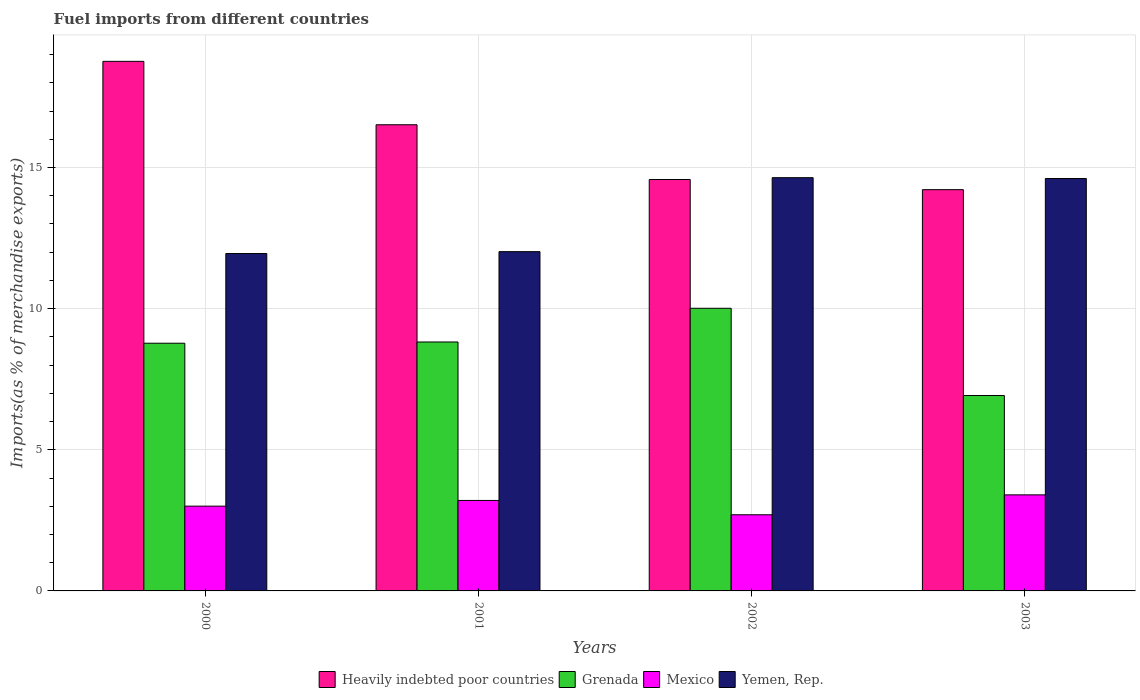How many groups of bars are there?
Provide a succinct answer. 4. Are the number of bars per tick equal to the number of legend labels?
Your answer should be compact. Yes. How many bars are there on the 3rd tick from the left?
Your response must be concise. 4. How many bars are there on the 4th tick from the right?
Your answer should be compact. 4. What is the label of the 1st group of bars from the left?
Your answer should be compact. 2000. In how many cases, is the number of bars for a given year not equal to the number of legend labels?
Provide a short and direct response. 0. What is the percentage of imports to different countries in Mexico in 2003?
Give a very brief answer. 3.4. Across all years, what is the maximum percentage of imports to different countries in Heavily indebted poor countries?
Keep it short and to the point. 18.76. Across all years, what is the minimum percentage of imports to different countries in Grenada?
Make the answer very short. 6.92. In which year was the percentage of imports to different countries in Heavily indebted poor countries minimum?
Give a very brief answer. 2003. What is the total percentage of imports to different countries in Heavily indebted poor countries in the graph?
Provide a succinct answer. 64.07. What is the difference between the percentage of imports to different countries in Mexico in 2000 and that in 2002?
Give a very brief answer. 0.31. What is the difference between the percentage of imports to different countries in Mexico in 2003 and the percentage of imports to different countries in Heavily indebted poor countries in 2002?
Your response must be concise. -11.17. What is the average percentage of imports to different countries in Mexico per year?
Ensure brevity in your answer.  3.08. In the year 2000, what is the difference between the percentage of imports to different countries in Grenada and percentage of imports to different countries in Mexico?
Make the answer very short. 5.77. What is the ratio of the percentage of imports to different countries in Grenada in 2002 to that in 2003?
Offer a terse response. 1.45. Is the difference between the percentage of imports to different countries in Grenada in 2000 and 2002 greater than the difference between the percentage of imports to different countries in Mexico in 2000 and 2002?
Offer a terse response. No. What is the difference between the highest and the second highest percentage of imports to different countries in Mexico?
Offer a very short reply. 0.2. What is the difference between the highest and the lowest percentage of imports to different countries in Mexico?
Your response must be concise. 0.71. Is it the case that in every year, the sum of the percentage of imports to different countries in Heavily indebted poor countries and percentage of imports to different countries in Grenada is greater than the sum of percentage of imports to different countries in Mexico and percentage of imports to different countries in Yemen, Rep.?
Provide a succinct answer. Yes. What does the 4th bar from the left in 2003 represents?
Your answer should be compact. Yemen, Rep. What does the 2nd bar from the right in 2002 represents?
Provide a succinct answer. Mexico. Are all the bars in the graph horizontal?
Ensure brevity in your answer.  No. Are the values on the major ticks of Y-axis written in scientific E-notation?
Your answer should be compact. No. Does the graph contain grids?
Provide a succinct answer. Yes. How many legend labels are there?
Your answer should be very brief. 4. What is the title of the graph?
Your answer should be compact. Fuel imports from different countries. What is the label or title of the Y-axis?
Keep it short and to the point. Imports(as % of merchandise exports). What is the Imports(as % of merchandise exports) in Heavily indebted poor countries in 2000?
Provide a succinct answer. 18.76. What is the Imports(as % of merchandise exports) in Grenada in 2000?
Your response must be concise. 8.78. What is the Imports(as % of merchandise exports) in Mexico in 2000?
Offer a very short reply. 3. What is the Imports(as % of merchandise exports) of Yemen, Rep. in 2000?
Provide a short and direct response. 11.95. What is the Imports(as % of merchandise exports) of Heavily indebted poor countries in 2001?
Offer a very short reply. 16.51. What is the Imports(as % of merchandise exports) in Grenada in 2001?
Provide a short and direct response. 8.82. What is the Imports(as % of merchandise exports) in Mexico in 2001?
Your answer should be very brief. 3.21. What is the Imports(as % of merchandise exports) of Yemen, Rep. in 2001?
Your answer should be compact. 12.02. What is the Imports(as % of merchandise exports) in Heavily indebted poor countries in 2002?
Keep it short and to the point. 14.58. What is the Imports(as % of merchandise exports) in Grenada in 2002?
Ensure brevity in your answer.  10.01. What is the Imports(as % of merchandise exports) in Mexico in 2002?
Offer a terse response. 2.7. What is the Imports(as % of merchandise exports) of Yemen, Rep. in 2002?
Offer a very short reply. 14.64. What is the Imports(as % of merchandise exports) of Heavily indebted poor countries in 2003?
Offer a terse response. 14.21. What is the Imports(as % of merchandise exports) of Grenada in 2003?
Offer a terse response. 6.92. What is the Imports(as % of merchandise exports) in Mexico in 2003?
Provide a short and direct response. 3.4. What is the Imports(as % of merchandise exports) in Yemen, Rep. in 2003?
Make the answer very short. 14.61. Across all years, what is the maximum Imports(as % of merchandise exports) in Heavily indebted poor countries?
Give a very brief answer. 18.76. Across all years, what is the maximum Imports(as % of merchandise exports) in Grenada?
Give a very brief answer. 10.01. Across all years, what is the maximum Imports(as % of merchandise exports) of Mexico?
Provide a succinct answer. 3.4. Across all years, what is the maximum Imports(as % of merchandise exports) of Yemen, Rep.?
Provide a succinct answer. 14.64. Across all years, what is the minimum Imports(as % of merchandise exports) of Heavily indebted poor countries?
Offer a very short reply. 14.21. Across all years, what is the minimum Imports(as % of merchandise exports) of Grenada?
Provide a succinct answer. 6.92. Across all years, what is the minimum Imports(as % of merchandise exports) in Mexico?
Your answer should be very brief. 2.7. Across all years, what is the minimum Imports(as % of merchandise exports) of Yemen, Rep.?
Offer a terse response. 11.95. What is the total Imports(as % of merchandise exports) of Heavily indebted poor countries in the graph?
Give a very brief answer. 64.07. What is the total Imports(as % of merchandise exports) in Grenada in the graph?
Keep it short and to the point. 34.53. What is the total Imports(as % of merchandise exports) in Mexico in the graph?
Provide a short and direct response. 12.31. What is the total Imports(as % of merchandise exports) in Yemen, Rep. in the graph?
Your response must be concise. 53.22. What is the difference between the Imports(as % of merchandise exports) of Heavily indebted poor countries in 2000 and that in 2001?
Offer a terse response. 2.25. What is the difference between the Imports(as % of merchandise exports) in Grenada in 2000 and that in 2001?
Your answer should be very brief. -0.04. What is the difference between the Imports(as % of merchandise exports) in Mexico in 2000 and that in 2001?
Keep it short and to the point. -0.2. What is the difference between the Imports(as % of merchandise exports) of Yemen, Rep. in 2000 and that in 2001?
Provide a succinct answer. -0.07. What is the difference between the Imports(as % of merchandise exports) of Heavily indebted poor countries in 2000 and that in 2002?
Provide a succinct answer. 4.19. What is the difference between the Imports(as % of merchandise exports) of Grenada in 2000 and that in 2002?
Offer a very short reply. -1.24. What is the difference between the Imports(as % of merchandise exports) of Mexico in 2000 and that in 2002?
Offer a terse response. 0.31. What is the difference between the Imports(as % of merchandise exports) of Yemen, Rep. in 2000 and that in 2002?
Provide a succinct answer. -2.69. What is the difference between the Imports(as % of merchandise exports) in Heavily indebted poor countries in 2000 and that in 2003?
Give a very brief answer. 4.55. What is the difference between the Imports(as % of merchandise exports) of Grenada in 2000 and that in 2003?
Make the answer very short. 1.85. What is the difference between the Imports(as % of merchandise exports) of Mexico in 2000 and that in 2003?
Provide a succinct answer. -0.4. What is the difference between the Imports(as % of merchandise exports) of Yemen, Rep. in 2000 and that in 2003?
Your answer should be very brief. -2.66. What is the difference between the Imports(as % of merchandise exports) in Heavily indebted poor countries in 2001 and that in 2002?
Provide a succinct answer. 1.94. What is the difference between the Imports(as % of merchandise exports) of Grenada in 2001 and that in 2002?
Your answer should be compact. -1.19. What is the difference between the Imports(as % of merchandise exports) in Mexico in 2001 and that in 2002?
Ensure brevity in your answer.  0.51. What is the difference between the Imports(as % of merchandise exports) of Yemen, Rep. in 2001 and that in 2002?
Provide a short and direct response. -2.62. What is the difference between the Imports(as % of merchandise exports) in Heavily indebted poor countries in 2001 and that in 2003?
Offer a terse response. 2.3. What is the difference between the Imports(as % of merchandise exports) of Grenada in 2001 and that in 2003?
Your answer should be compact. 1.9. What is the difference between the Imports(as % of merchandise exports) in Mexico in 2001 and that in 2003?
Make the answer very short. -0.2. What is the difference between the Imports(as % of merchandise exports) in Yemen, Rep. in 2001 and that in 2003?
Your answer should be compact. -2.59. What is the difference between the Imports(as % of merchandise exports) in Heavily indebted poor countries in 2002 and that in 2003?
Make the answer very short. 0.36. What is the difference between the Imports(as % of merchandise exports) of Grenada in 2002 and that in 2003?
Offer a terse response. 3.09. What is the difference between the Imports(as % of merchandise exports) of Mexico in 2002 and that in 2003?
Your response must be concise. -0.71. What is the difference between the Imports(as % of merchandise exports) in Yemen, Rep. in 2002 and that in 2003?
Provide a short and direct response. 0.03. What is the difference between the Imports(as % of merchandise exports) of Heavily indebted poor countries in 2000 and the Imports(as % of merchandise exports) of Grenada in 2001?
Provide a short and direct response. 9.94. What is the difference between the Imports(as % of merchandise exports) of Heavily indebted poor countries in 2000 and the Imports(as % of merchandise exports) of Mexico in 2001?
Your answer should be very brief. 15.56. What is the difference between the Imports(as % of merchandise exports) of Heavily indebted poor countries in 2000 and the Imports(as % of merchandise exports) of Yemen, Rep. in 2001?
Your answer should be very brief. 6.74. What is the difference between the Imports(as % of merchandise exports) of Grenada in 2000 and the Imports(as % of merchandise exports) of Mexico in 2001?
Offer a very short reply. 5.57. What is the difference between the Imports(as % of merchandise exports) in Grenada in 2000 and the Imports(as % of merchandise exports) in Yemen, Rep. in 2001?
Offer a terse response. -3.24. What is the difference between the Imports(as % of merchandise exports) of Mexico in 2000 and the Imports(as % of merchandise exports) of Yemen, Rep. in 2001?
Keep it short and to the point. -9.02. What is the difference between the Imports(as % of merchandise exports) of Heavily indebted poor countries in 2000 and the Imports(as % of merchandise exports) of Grenada in 2002?
Your answer should be compact. 8.75. What is the difference between the Imports(as % of merchandise exports) of Heavily indebted poor countries in 2000 and the Imports(as % of merchandise exports) of Mexico in 2002?
Your response must be concise. 16.06. What is the difference between the Imports(as % of merchandise exports) of Heavily indebted poor countries in 2000 and the Imports(as % of merchandise exports) of Yemen, Rep. in 2002?
Your answer should be compact. 4.12. What is the difference between the Imports(as % of merchandise exports) of Grenada in 2000 and the Imports(as % of merchandise exports) of Mexico in 2002?
Make the answer very short. 6.08. What is the difference between the Imports(as % of merchandise exports) of Grenada in 2000 and the Imports(as % of merchandise exports) of Yemen, Rep. in 2002?
Ensure brevity in your answer.  -5.86. What is the difference between the Imports(as % of merchandise exports) in Mexico in 2000 and the Imports(as % of merchandise exports) in Yemen, Rep. in 2002?
Provide a short and direct response. -11.64. What is the difference between the Imports(as % of merchandise exports) of Heavily indebted poor countries in 2000 and the Imports(as % of merchandise exports) of Grenada in 2003?
Your answer should be very brief. 11.84. What is the difference between the Imports(as % of merchandise exports) in Heavily indebted poor countries in 2000 and the Imports(as % of merchandise exports) in Mexico in 2003?
Make the answer very short. 15.36. What is the difference between the Imports(as % of merchandise exports) in Heavily indebted poor countries in 2000 and the Imports(as % of merchandise exports) in Yemen, Rep. in 2003?
Ensure brevity in your answer.  4.15. What is the difference between the Imports(as % of merchandise exports) in Grenada in 2000 and the Imports(as % of merchandise exports) in Mexico in 2003?
Give a very brief answer. 5.37. What is the difference between the Imports(as % of merchandise exports) of Grenada in 2000 and the Imports(as % of merchandise exports) of Yemen, Rep. in 2003?
Make the answer very short. -5.84. What is the difference between the Imports(as % of merchandise exports) of Mexico in 2000 and the Imports(as % of merchandise exports) of Yemen, Rep. in 2003?
Your response must be concise. -11.61. What is the difference between the Imports(as % of merchandise exports) of Heavily indebted poor countries in 2001 and the Imports(as % of merchandise exports) of Grenada in 2002?
Offer a very short reply. 6.5. What is the difference between the Imports(as % of merchandise exports) in Heavily indebted poor countries in 2001 and the Imports(as % of merchandise exports) in Mexico in 2002?
Offer a terse response. 13.82. What is the difference between the Imports(as % of merchandise exports) of Heavily indebted poor countries in 2001 and the Imports(as % of merchandise exports) of Yemen, Rep. in 2002?
Offer a very short reply. 1.87. What is the difference between the Imports(as % of merchandise exports) of Grenada in 2001 and the Imports(as % of merchandise exports) of Mexico in 2002?
Make the answer very short. 6.12. What is the difference between the Imports(as % of merchandise exports) in Grenada in 2001 and the Imports(as % of merchandise exports) in Yemen, Rep. in 2002?
Keep it short and to the point. -5.82. What is the difference between the Imports(as % of merchandise exports) in Mexico in 2001 and the Imports(as % of merchandise exports) in Yemen, Rep. in 2002?
Provide a succinct answer. -11.43. What is the difference between the Imports(as % of merchandise exports) in Heavily indebted poor countries in 2001 and the Imports(as % of merchandise exports) in Grenada in 2003?
Keep it short and to the point. 9.59. What is the difference between the Imports(as % of merchandise exports) of Heavily indebted poor countries in 2001 and the Imports(as % of merchandise exports) of Mexico in 2003?
Ensure brevity in your answer.  13.11. What is the difference between the Imports(as % of merchandise exports) in Heavily indebted poor countries in 2001 and the Imports(as % of merchandise exports) in Yemen, Rep. in 2003?
Offer a terse response. 1.9. What is the difference between the Imports(as % of merchandise exports) of Grenada in 2001 and the Imports(as % of merchandise exports) of Mexico in 2003?
Offer a terse response. 5.42. What is the difference between the Imports(as % of merchandise exports) of Grenada in 2001 and the Imports(as % of merchandise exports) of Yemen, Rep. in 2003?
Ensure brevity in your answer.  -5.79. What is the difference between the Imports(as % of merchandise exports) of Mexico in 2001 and the Imports(as % of merchandise exports) of Yemen, Rep. in 2003?
Make the answer very short. -11.41. What is the difference between the Imports(as % of merchandise exports) of Heavily indebted poor countries in 2002 and the Imports(as % of merchandise exports) of Grenada in 2003?
Give a very brief answer. 7.65. What is the difference between the Imports(as % of merchandise exports) of Heavily indebted poor countries in 2002 and the Imports(as % of merchandise exports) of Mexico in 2003?
Make the answer very short. 11.17. What is the difference between the Imports(as % of merchandise exports) of Heavily indebted poor countries in 2002 and the Imports(as % of merchandise exports) of Yemen, Rep. in 2003?
Give a very brief answer. -0.03. What is the difference between the Imports(as % of merchandise exports) in Grenada in 2002 and the Imports(as % of merchandise exports) in Mexico in 2003?
Keep it short and to the point. 6.61. What is the difference between the Imports(as % of merchandise exports) in Grenada in 2002 and the Imports(as % of merchandise exports) in Yemen, Rep. in 2003?
Keep it short and to the point. -4.6. What is the difference between the Imports(as % of merchandise exports) of Mexico in 2002 and the Imports(as % of merchandise exports) of Yemen, Rep. in 2003?
Your response must be concise. -11.91. What is the average Imports(as % of merchandise exports) in Heavily indebted poor countries per year?
Ensure brevity in your answer.  16.02. What is the average Imports(as % of merchandise exports) in Grenada per year?
Provide a short and direct response. 8.63. What is the average Imports(as % of merchandise exports) of Mexico per year?
Your answer should be compact. 3.08. What is the average Imports(as % of merchandise exports) in Yemen, Rep. per year?
Your response must be concise. 13.31. In the year 2000, what is the difference between the Imports(as % of merchandise exports) in Heavily indebted poor countries and Imports(as % of merchandise exports) in Grenada?
Keep it short and to the point. 9.99. In the year 2000, what is the difference between the Imports(as % of merchandise exports) in Heavily indebted poor countries and Imports(as % of merchandise exports) in Mexico?
Your answer should be very brief. 15.76. In the year 2000, what is the difference between the Imports(as % of merchandise exports) in Heavily indebted poor countries and Imports(as % of merchandise exports) in Yemen, Rep.?
Provide a succinct answer. 6.81. In the year 2000, what is the difference between the Imports(as % of merchandise exports) in Grenada and Imports(as % of merchandise exports) in Mexico?
Provide a succinct answer. 5.77. In the year 2000, what is the difference between the Imports(as % of merchandise exports) of Grenada and Imports(as % of merchandise exports) of Yemen, Rep.?
Ensure brevity in your answer.  -3.18. In the year 2000, what is the difference between the Imports(as % of merchandise exports) of Mexico and Imports(as % of merchandise exports) of Yemen, Rep.?
Make the answer very short. -8.95. In the year 2001, what is the difference between the Imports(as % of merchandise exports) of Heavily indebted poor countries and Imports(as % of merchandise exports) of Grenada?
Give a very brief answer. 7.7. In the year 2001, what is the difference between the Imports(as % of merchandise exports) in Heavily indebted poor countries and Imports(as % of merchandise exports) in Mexico?
Provide a succinct answer. 13.31. In the year 2001, what is the difference between the Imports(as % of merchandise exports) in Heavily indebted poor countries and Imports(as % of merchandise exports) in Yemen, Rep.?
Make the answer very short. 4.49. In the year 2001, what is the difference between the Imports(as % of merchandise exports) of Grenada and Imports(as % of merchandise exports) of Mexico?
Offer a very short reply. 5.61. In the year 2001, what is the difference between the Imports(as % of merchandise exports) of Grenada and Imports(as % of merchandise exports) of Yemen, Rep.?
Offer a very short reply. -3.2. In the year 2001, what is the difference between the Imports(as % of merchandise exports) in Mexico and Imports(as % of merchandise exports) in Yemen, Rep.?
Offer a terse response. -8.81. In the year 2002, what is the difference between the Imports(as % of merchandise exports) of Heavily indebted poor countries and Imports(as % of merchandise exports) of Grenada?
Give a very brief answer. 4.56. In the year 2002, what is the difference between the Imports(as % of merchandise exports) in Heavily indebted poor countries and Imports(as % of merchandise exports) in Mexico?
Make the answer very short. 11.88. In the year 2002, what is the difference between the Imports(as % of merchandise exports) in Heavily indebted poor countries and Imports(as % of merchandise exports) in Yemen, Rep.?
Provide a short and direct response. -0.06. In the year 2002, what is the difference between the Imports(as % of merchandise exports) in Grenada and Imports(as % of merchandise exports) in Mexico?
Provide a short and direct response. 7.32. In the year 2002, what is the difference between the Imports(as % of merchandise exports) of Grenada and Imports(as % of merchandise exports) of Yemen, Rep.?
Your response must be concise. -4.63. In the year 2002, what is the difference between the Imports(as % of merchandise exports) in Mexico and Imports(as % of merchandise exports) in Yemen, Rep.?
Your answer should be compact. -11.94. In the year 2003, what is the difference between the Imports(as % of merchandise exports) in Heavily indebted poor countries and Imports(as % of merchandise exports) in Grenada?
Provide a succinct answer. 7.29. In the year 2003, what is the difference between the Imports(as % of merchandise exports) of Heavily indebted poor countries and Imports(as % of merchandise exports) of Mexico?
Make the answer very short. 10.81. In the year 2003, what is the difference between the Imports(as % of merchandise exports) of Heavily indebted poor countries and Imports(as % of merchandise exports) of Yemen, Rep.?
Offer a terse response. -0.4. In the year 2003, what is the difference between the Imports(as % of merchandise exports) in Grenada and Imports(as % of merchandise exports) in Mexico?
Offer a very short reply. 3.52. In the year 2003, what is the difference between the Imports(as % of merchandise exports) of Grenada and Imports(as % of merchandise exports) of Yemen, Rep.?
Your answer should be very brief. -7.69. In the year 2003, what is the difference between the Imports(as % of merchandise exports) of Mexico and Imports(as % of merchandise exports) of Yemen, Rep.?
Your answer should be very brief. -11.21. What is the ratio of the Imports(as % of merchandise exports) of Heavily indebted poor countries in 2000 to that in 2001?
Provide a succinct answer. 1.14. What is the ratio of the Imports(as % of merchandise exports) of Grenada in 2000 to that in 2001?
Provide a short and direct response. 1. What is the ratio of the Imports(as % of merchandise exports) in Mexico in 2000 to that in 2001?
Provide a succinct answer. 0.94. What is the ratio of the Imports(as % of merchandise exports) of Yemen, Rep. in 2000 to that in 2001?
Provide a short and direct response. 0.99. What is the ratio of the Imports(as % of merchandise exports) of Heavily indebted poor countries in 2000 to that in 2002?
Ensure brevity in your answer.  1.29. What is the ratio of the Imports(as % of merchandise exports) in Grenada in 2000 to that in 2002?
Provide a succinct answer. 0.88. What is the ratio of the Imports(as % of merchandise exports) of Mexico in 2000 to that in 2002?
Give a very brief answer. 1.11. What is the ratio of the Imports(as % of merchandise exports) of Yemen, Rep. in 2000 to that in 2002?
Provide a short and direct response. 0.82. What is the ratio of the Imports(as % of merchandise exports) of Heavily indebted poor countries in 2000 to that in 2003?
Offer a terse response. 1.32. What is the ratio of the Imports(as % of merchandise exports) in Grenada in 2000 to that in 2003?
Keep it short and to the point. 1.27. What is the ratio of the Imports(as % of merchandise exports) in Mexico in 2000 to that in 2003?
Give a very brief answer. 0.88. What is the ratio of the Imports(as % of merchandise exports) in Yemen, Rep. in 2000 to that in 2003?
Offer a very short reply. 0.82. What is the ratio of the Imports(as % of merchandise exports) in Heavily indebted poor countries in 2001 to that in 2002?
Your answer should be compact. 1.13. What is the ratio of the Imports(as % of merchandise exports) in Grenada in 2001 to that in 2002?
Make the answer very short. 0.88. What is the ratio of the Imports(as % of merchandise exports) in Mexico in 2001 to that in 2002?
Your response must be concise. 1.19. What is the ratio of the Imports(as % of merchandise exports) in Yemen, Rep. in 2001 to that in 2002?
Your response must be concise. 0.82. What is the ratio of the Imports(as % of merchandise exports) in Heavily indebted poor countries in 2001 to that in 2003?
Your answer should be compact. 1.16. What is the ratio of the Imports(as % of merchandise exports) of Grenada in 2001 to that in 2003?
Your answer should be compact. 1.27. What is the ratio of the Imports(as % of merchandise exports) in Mexico in 2001 to that in 2003?
Your answer should be very brief. 0.94. What is the ratio of the Imports(as % of merchandise exports) in Yemen, Rep. in 2001 to that in 2003?
Your response must be concise. 0.82. What is the ratio of the Imports(as % of merchandise exports) in Heavily indebted poor countries in 2002 to that in 2003?
Ensure brevity in your answer.  1.03. What is the ratio of the Imports(as % of merchandise exports) of Grenada in 2002 to that in 2003?
Your answer should be compact. 1.45. What is the ratio of the Imports(as % of merchandise exports) in Mexico in 2002 to that in 2003?
Your answer should be compact. 0.79. What is the difference between the highest and the second highest Imports(as % of merchandise exports) in Heavily indebted poor countries?
Your answer should be compact. 2.25. What is the difference between the highest and the second highest Imports(as % of merchandise exports) of Grenada?
Your answer should be compact. 1.19. What is the difference between the highest and the second highest Imports(as % of merchandise exports) of Mexico?
Provide a short and direct response. 0.2. What is the difference between the highest and the second highest Imports(as % of merchandise exports) of Yemen, Rep.?
Make the answer very short. 0.03. What is the difference between the highest and the lowest Imports(as % of merchandise exports) in Heavily indebted poor countries?
Offer a very short reply. 4.55. What is the difference between the highest and the lowest Imports(as % of merchandise exports) of Grenada?
Your response must be concise. 3.09. What is the difference between the highest and the lowest Imports(as % of merchandise exports) in Mexico?
Ensure brevity in your answer.  0.71. What is the difference between the highest and the lowest Imports(as % of merchandise exports) of Yemen, Rep.?
Offer a terse response. 2.69. 